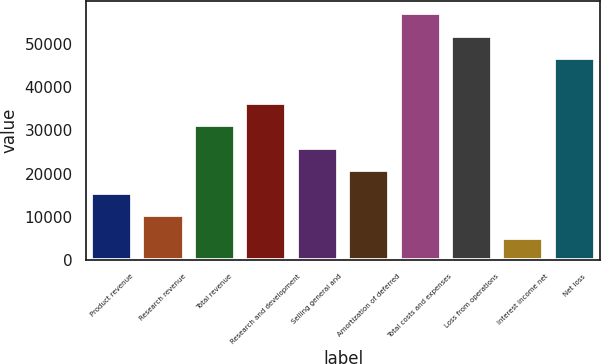Convert chart. <chart><loc_0><loc_0><loc_500><loc_500><bar_chart><fcel>Product revenue<fcel>Research revenue<fcel>Total revenue<fcel>Research and development<fcel>Selling general and<fcel>Amortization of deferred<fcel>Total costs and expenses<fcel>Loss from operations<fcel>Interest income net<fcel>Net loss<nl><fcel>15569.4<fcel>10380<fcel>31137.5<fcel>36326.9<fcel>25948.2<fcel>20758.8<fcel>57084.4<fcel>51895<fcel>5190.68<fcel>46705.6<nl></chart> 